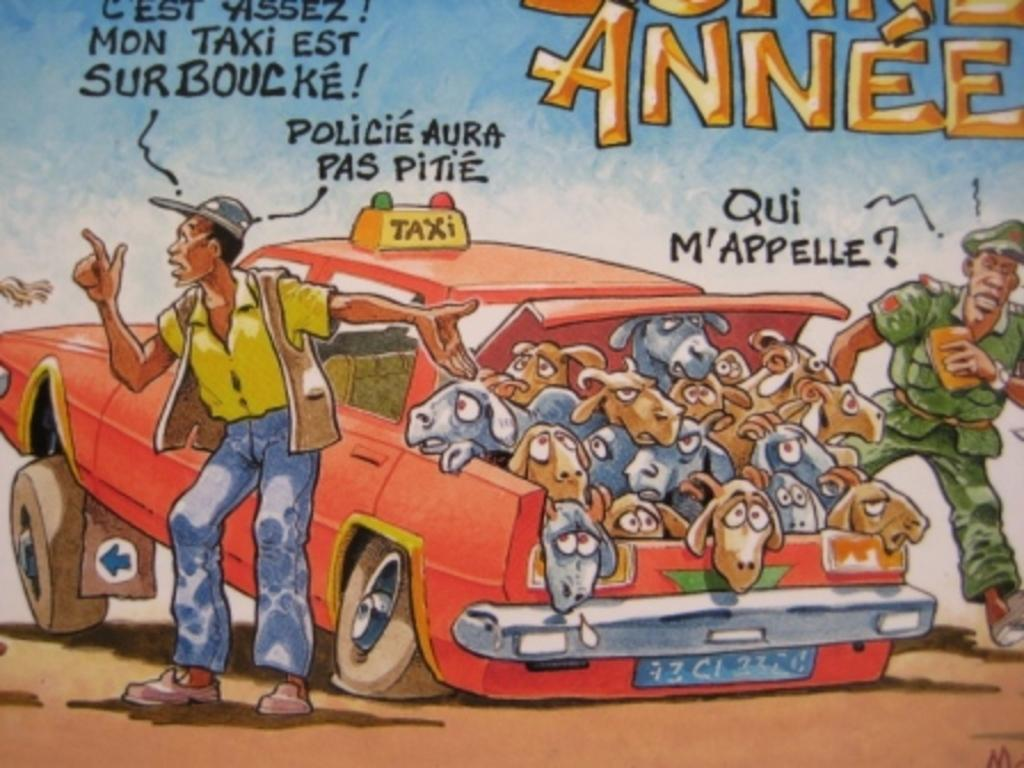What type of vehicle is present in the image? There is a red car in the image. What is inside the red car? There are animals in the red car. Are there any people visible in the image? Yes, people are standing in the image. What type of soup is being served in the image? There is no soup present in the image. What is the feeling of the people standing in the image? The provided facts do not give any information about the feelings of the people in the image. 